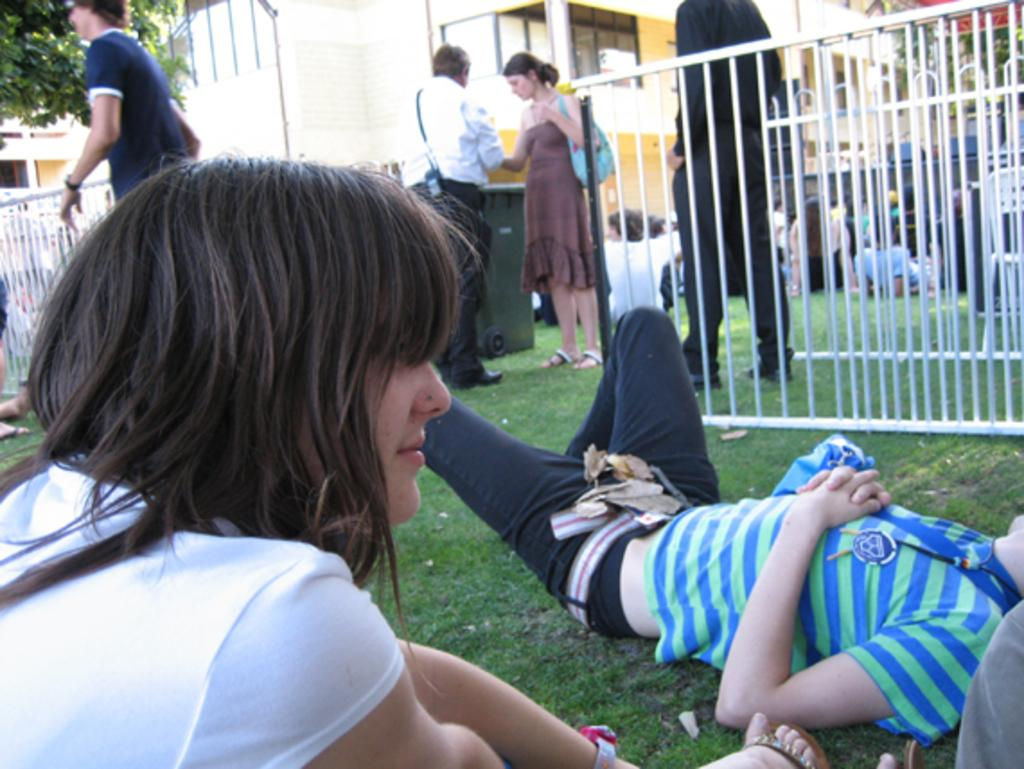What is the position of the person in the image? There is a person lying on the path in the image. What are the other people in the image doing? There are people sitting and standing in the image. What can be seen in the background of the image? There is a fence, trees, and a building visible in the background of the image. What type of light can be seen reflecting off the river in the image? There is no river present in the image, so there is no light reflecting off it. What is the person using to hammer nails in the image? There is no hammer or nails present in the image. 